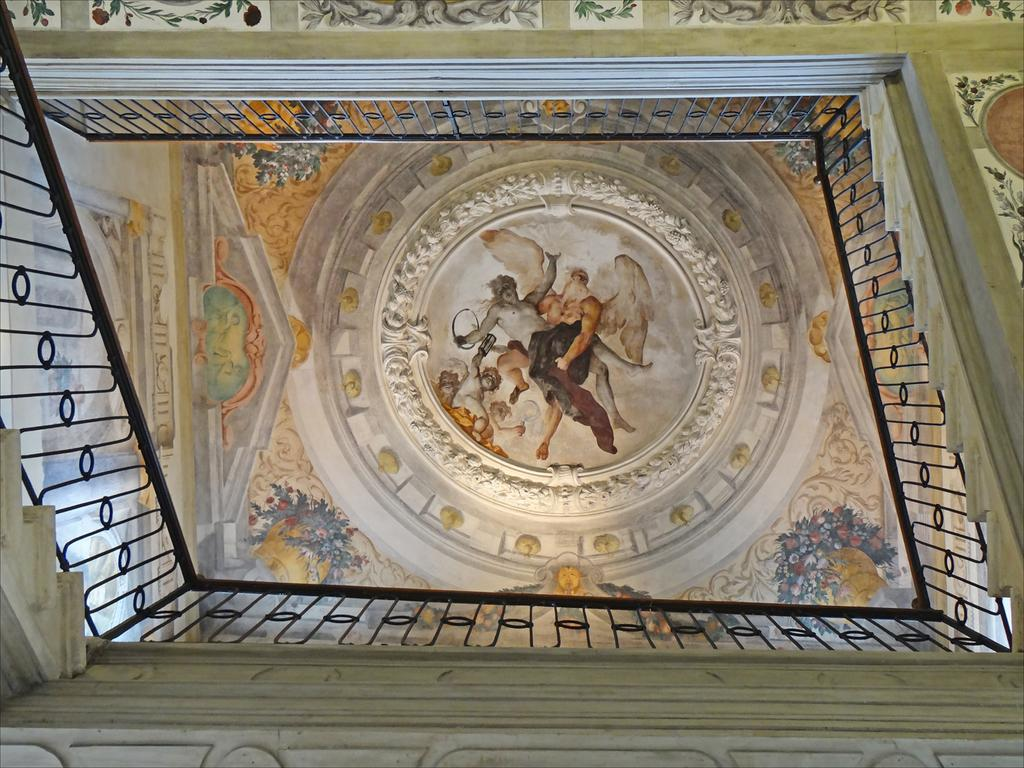What type of artwork can be seen in the image? There are sculptures in the image. Where are the sculptures located? The sculptures are inside a building. Can you describe the building's architectural style? The building has an old architectural style. What type of security feature is present in the image? There are iron grills in the image. Can you tell me what type of tub is present in the image? There is no tub present in the image. How many crows can be seen in the image? There are no crows present in the image. 